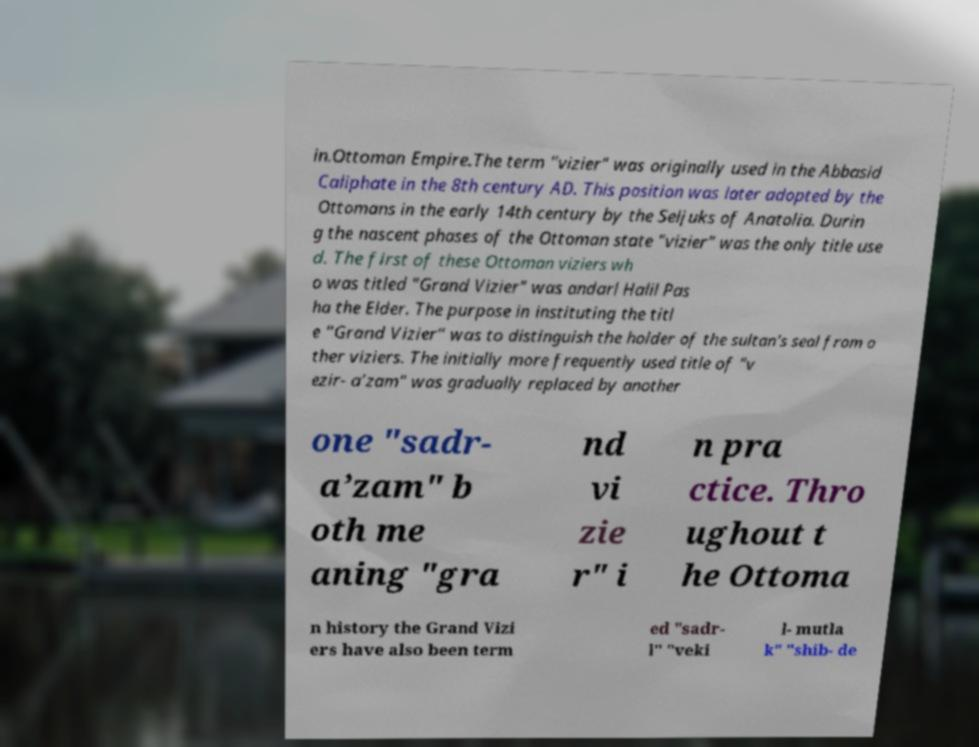What messages or text are displayed in this image? I need them in a readable, typed format. in.Ottoman Empire.The term "vizier" was originally used in the Abbasid Caliphate in the 8th century AD. This position was later adopted by the Ottomans in the early 14th century by the Seljuks of Anatolia. Durin g the nascent phases of the Ottoman state "vizier" was the only title use d. The first of these Ottoman viziers wh o was titled "Grand Vizier" was andarl Halil Pas ha the Elder. The purpose in instituting the titl e "Grand Vizier" was to distinguish the holder of the sultan's seal from o ther viziers. The initially more frequently used title of "v ezir- a’zam" was gradually replaced by another one "sadr- a’zam" b oth me aning "gra nd vi zie r" i n pra ctice. Thro ughout t he Ottoma n history the Grand Vizi ers have also been term ed "sadr- l" "veki l- mutla k" "shib- de 